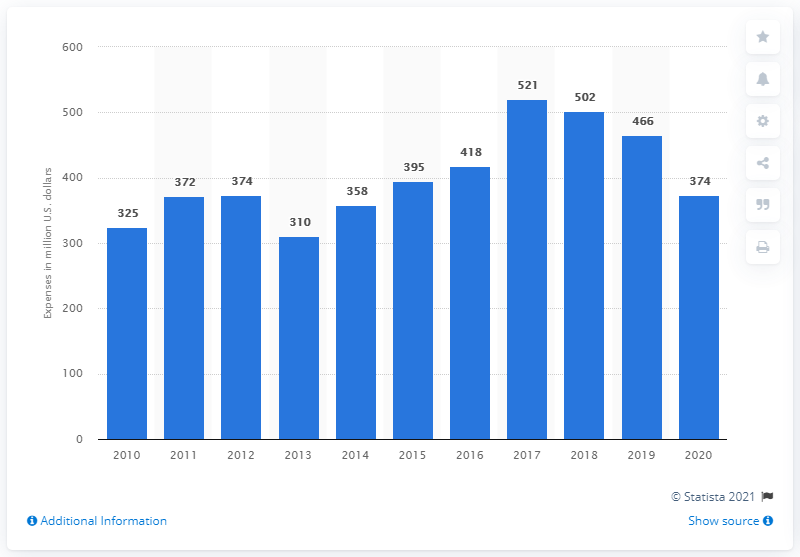What could have caused the fluctuations in R&D spending over this period? Various factors could contribute to the fluctuations in R&D spending, including changes in company strategy, market conditions, government defense budgets as General Dynamics is a defense contractor, and macroeconomic events that may influence budget allocations and investment priorities. 